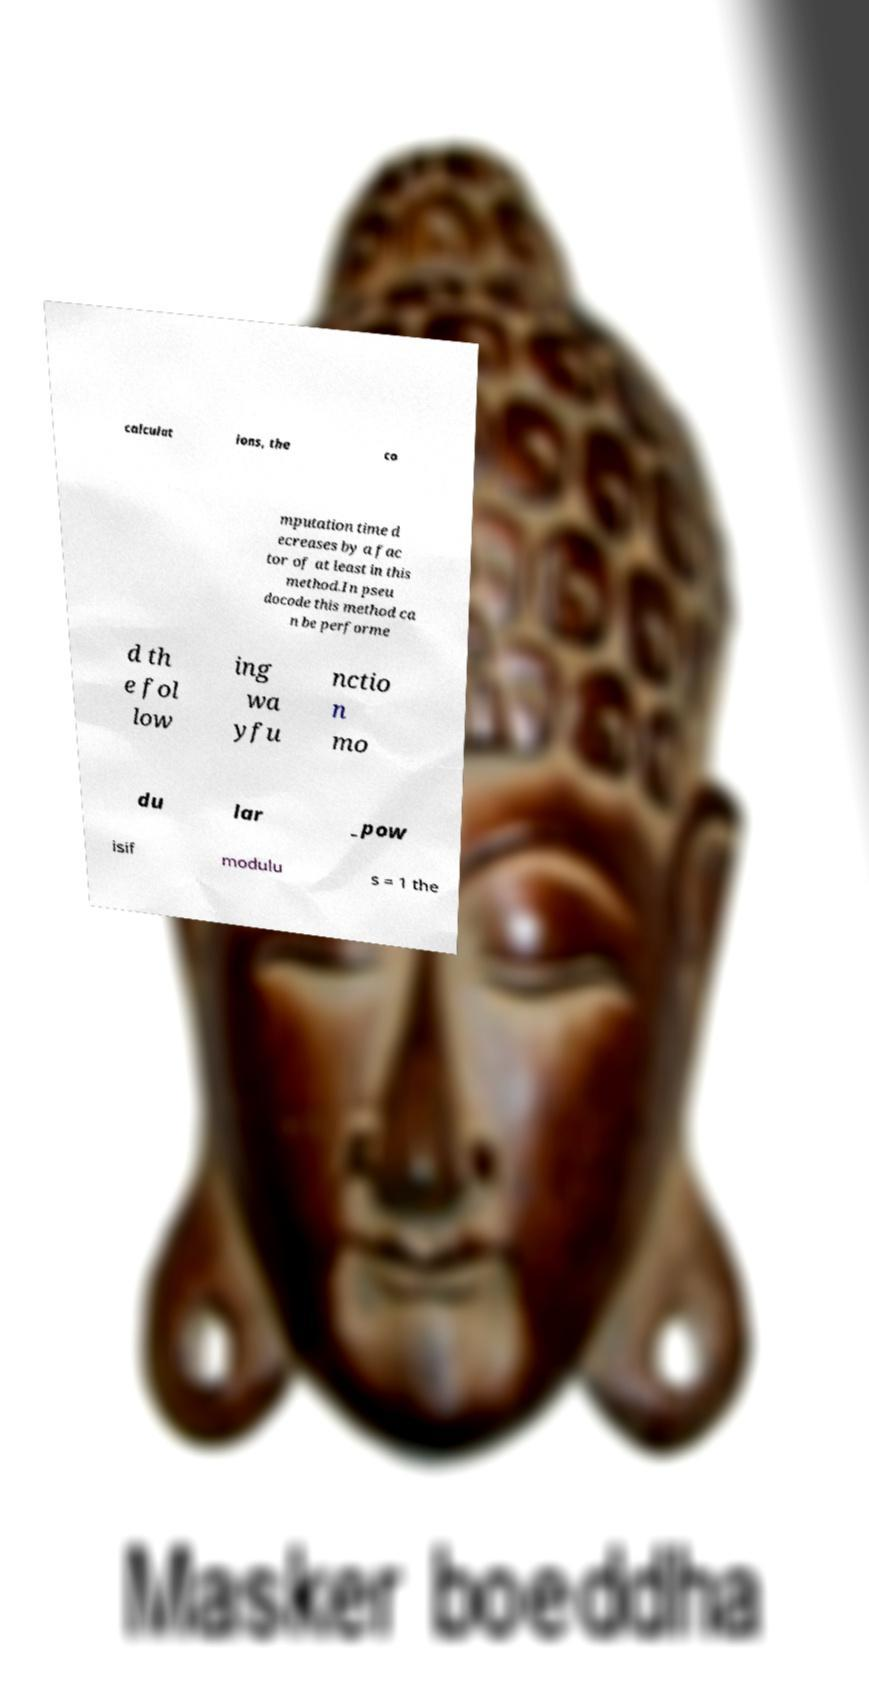Please read and relay the text visible in this image. What does it say? calculat ions, the co mputation time d ecreases by a fac tor of at least in this method.In pseu docode this method ca n be performe d th e fol low ing wa yfu nctio n mo du lar _pow isif modulu s = 1 the 